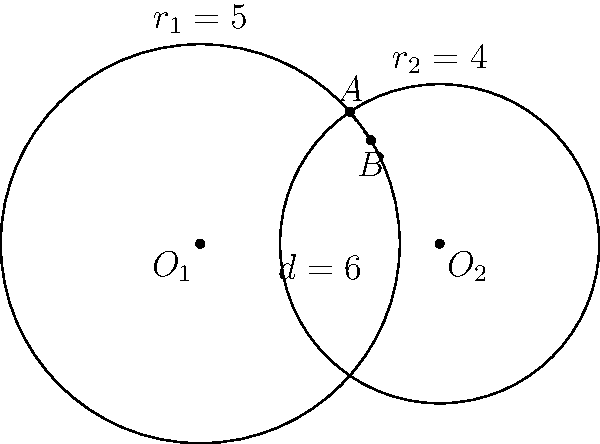In a healthcare facility, two circular treatment areas overlap. The centers of these areas are 6 units apart. The radius of the larger area is 5 units, and the radius of the smaller area is 4 units. Calculate the length of the common chord (the line segment where the two circular areas intersect) to determine the optimal shared space for patient care. Let's approach this step-by-step:

1) First, we need to recall the formula for the length of a common chord between two intersecting circles. If $d$ is the distance between the centers, $r_1$ and $r_2$ are the radii, and $a$ is half the length of the common chord, then:

   $$a^2 = \frac{(-d+r_1+r_2)(d+r_1-r_2)(d-r_1+r_2)(d+r_1+r_2)}{4d^2}$$

2) We're given:
   $d = 6$ (distance between centers)
   $r_1 = 5$ (radius of larger circle)
   $r_2 = 4$ (radius of smaller circle)

3) Let's substitute these values into our formula:

   $$a^2 = \frac{(-6+5+4)(6+5-4)(6-5+4)(6+5+4)}{4(6^2)}$$

4) Simplify inside the parentheses:

   $$a^2 = \frac{(3)(7)(5)(15)}{144}$$

5) Multiply the numerator:

   $$a^2 = \frac{1575}{144}$$

6) Simplify:

   $$a^2 = 10.9375$$

7) Take the square root of both sides:

   $$a = \sqrt{10.9375} \approx 3.307$$

8) Remember, $a$ is half the length of the common chord. To get the full length, we need to double this:

   Length of common chord $= 2a \approx 2(3.307) = 6.614$

Therefore, the length of the common chord is approximately 6.614 units.
Answer: 6.614 units 